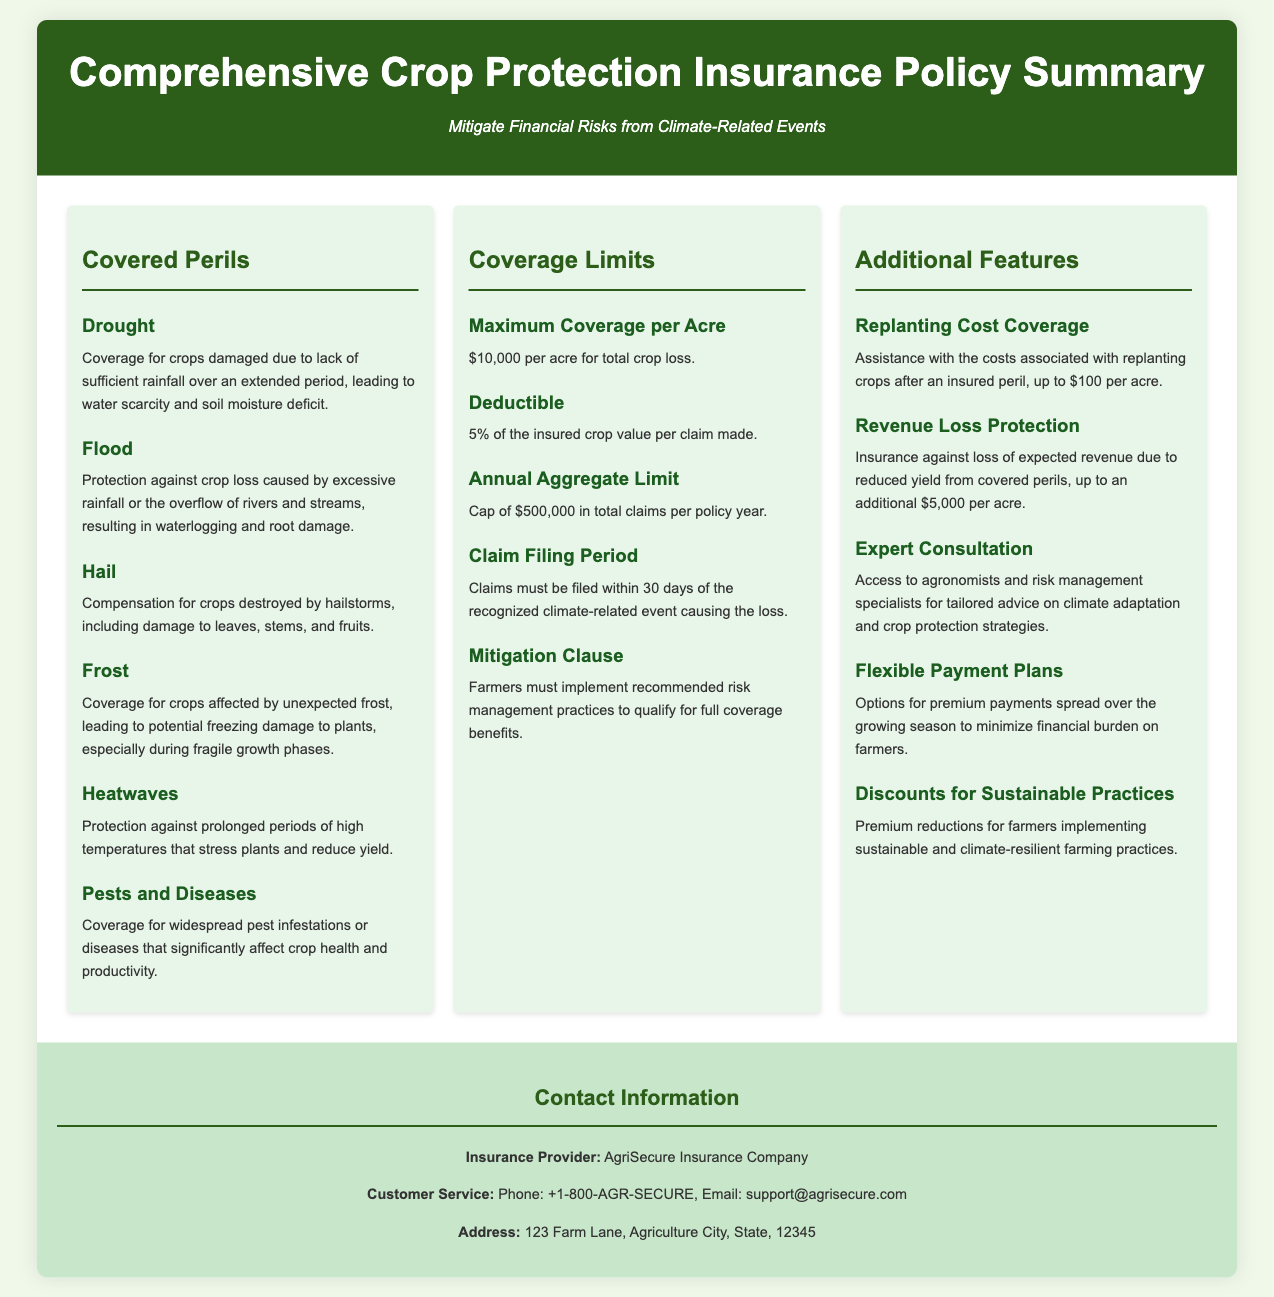What is the maximum coverage per acre? The maximum coverage per acre is specified in the Coverage Limits section of the document.
Answer: $10,000 per acre What is the deductible amount? The deductible amount is found under the Coverage Limits section, indicating the percentage of insured crop value payable per claim.
Answer: 5% What is the annual aggregate limit? The annual aggregate limit is stated as the total claims cap per policy year in the Coverage Limits section.
Answer: $500,000 Which peril is associated with damage from excessive rainfall? This pertains to crop loss caused by certain weather conditions outlined in the Covered Perils section.
Answer: Flood What is the claim filing period? The claim filing period can be found in the Coverage Limits section, indicating the allowable time frame for submitting claims.
Answer: 30 days What type of coverage is offered for help with replanting costs? This is detailed under the Additional Features section, referring to assistance after an insured peril.
Answer: Replanting Cost Coverage What is the coverage limit for revenue loss protection per acre? This limit is specified in the Additional Features section, detailing the insurance against expected revenue loss.
Answer: $5,000 per acre What entity provides this insurance policy? The insurance provider is identified in the Contact Information section of the document.
Answer: AgriSecure Insurance Company What benefit is provided for implementing sustainable practices? This benefit is mentioned in the Additional Features section, relating to premium adjustments based on farming methods.
Answer: Discounts for Sustainable Practices 